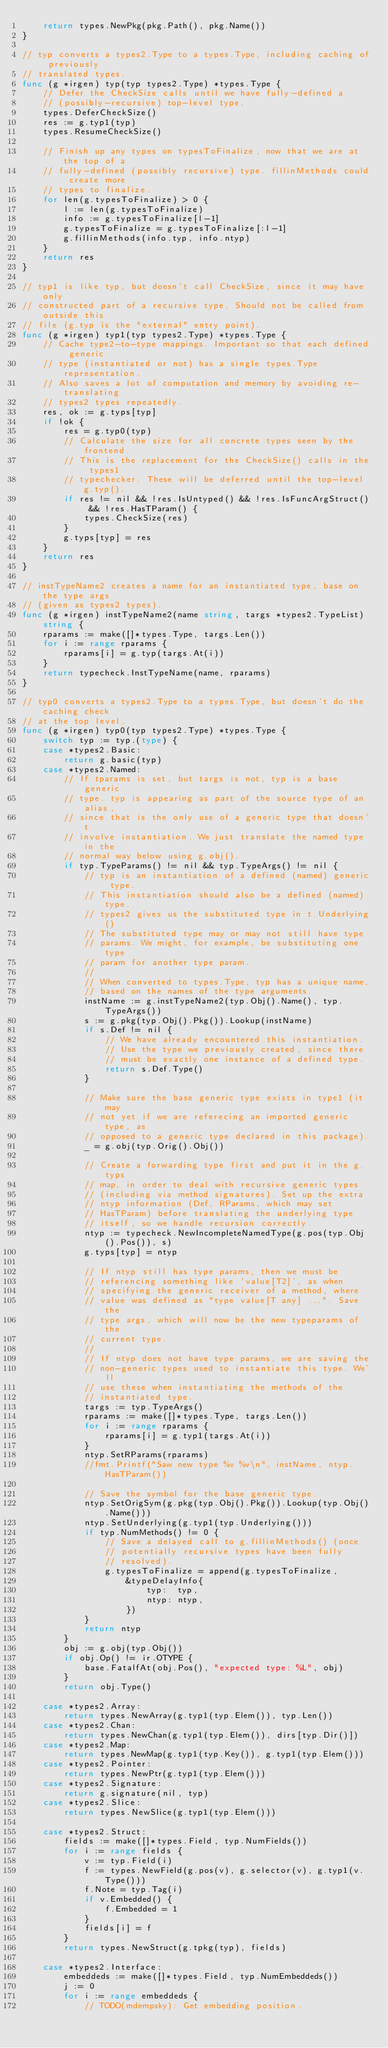Convert code to text. <code><loc_0><loc_0><loc_500><loc_500><_Go_>	return types.NewPkg(pkg.Path(), pkg.Name())
}

// typ converts a types2.Type to a types.Type, including caching of previously
// translated types.
func (g *irgen) typ(typ types2.Type) *types.Type {
	// Defer the CheckSize calls until we have fully-defined a
	// (possibly-recursive) top-level type.
	types.DeferCheckSize()
	res := g.typ1(typ)
	types.ResumeCheckSize()

	// Finish up any types on typesToFinalize, now that we are at the top of a
	// fully-defined (possibly recursive) type. fillinMethods could create more
	// types to finalize.
	for len(g.typesToFinalize) > 0 {
		l := len(g.typesToFinalize)
		info := g.typesToFinalize[l-1]
		g.typesToFinalize = g.typesToFinalize[:l-1]
		g.fillinMethods(info.typ, info.ntyp)
	}
	return res
}

// typ1 is like typ, but doesn't call CheckSize, since it may have only
// constructed part of a recursive type. Should not be called from outside this
// file (g.typ is the "external" entry point).
func (g *irgen) typ1(typ types2.Type) *types.Type {
	// Cache type2-to-type mappings. Important so that each defined generic
	// type (instantiated or not) has a single types.Type representation.
	// Also saves a lot of computation and memory by avoiding re-translating
	// types2 types repeatedly.
	res, ok := g.typs[typ]
	if !ok {
		res = g.typ0(typ)
		// Calculate the size for all concrete types seen by the frontend.
		// This is the replacement for the CheckSize() calls in the types1
		// typechecker. These will be deferred until the top-level g.typ().
		if res != nil && !res.IsUntyped() && !res.IsFuncArgStruct() && !res.HasTParam() {
			types.CheckSize(res)
		}
		g.typs[typ] = res
	}
	return res
}

// instTypeName2 creates a name for an instantiated type, base on the type args
// (given as types2 types).
func (g *irgen) instTypeName2(name string, targs *types2.TypeList) string {
	rparams := make([]*types.Type, targs.Len())
	for i := range rparams {
		rparams[i] = g.typ(targs.At(i))
	}
	return typecheck.InstTypeName(name, rparams)
}

// typ0 converts a types2.Type to a types.Type, but doesn't do the caching check
// at the top level.
func (g *irgen) typ0(typ types2.Type) *types.Type {
	switch typ := typ.(type) {
	case *types2.Basic:
		return g.basic(typ)
	case *types2.Named:
		// If tparams is set, but targs is not, typ is a base generic
		// type. typ is appearing as part of the source type of an alias,
		// since that is the only use of a generic type that doesn't
		// involve instantiation. We just translate the named type in the
		// normal way below using g.obj().
		if typ.TypeParams() != nil && typ.TypeArgs() != nil {
			// typ is an instantiation of a defined (named) generic type.
			// This instantiation should also be a defined (named) type.
			// types2 gives us the substituted type in t.Underlying()
			// The substituted type may or may not still have type
			// params. We might, for example, be substituting one type
			// param for another type param.
			//
			// When converted to types.Type, typ has a unique name,
			// based on the names of the type arguments.
			instName := g.instTypeName2(typ.Obj().Name(), typ.TypeArgs())
			s := g.pkg(typ.Obj().Pkg()).Lookup(instName)
			if s.Def != nil {
				// We have already encountered this instantiation.
				// Use the type we previously created, since there
				// must be exactly one instance of a defined type.
				return s.Def.Type()
			}

			// Make sure the base generic type exists in type1 (it may
			// not yet if we are referecing an imported generic type, as
			// opposed to a generic type declared in this package).
			_ = g.obj(typ.Orig().Obj())

			// Create a forwarding type first and put it in the g.typs
			// map, in order to deal with recursive generic types
			// (including via method signatures). Set up the extra
			// ntyp information (Def, RParams, which may set
			// HasTParam) before translating the underlying type
			// itself, so we handle recursion correctly.
			ntyp := typecheck.NewIncompleteNamedType(g.pos(typ.Obj().Pos()), s)
			g.typs[typ] = ntyp

			// If ntyp still has type params, then we must be
			// referencing something like 'value[T2]', as when
			// specifying the generic receiver of a method, where
			// value was defined as "type value[T any] ...". Save the
			// type args, which will now be the new typeparams of the
			// current type.
			//
			// If ntyp does not have type params, we are saving the
			// non-generic types used to instantiate this type. We'll
			// use these when instantiating the methods of the
			// instantiated type.
			targs := typ.TypeArgs()
			rparams := make([]*types.Type, targs.Len())
			for i := range rparams {
				rparams[i] = g.typ1(targs.At(i))
			}
			ntyp.SetRParams(rparams)
			//fmt.Printf("Saw new type %v %v\n", instName, ntyp.HasTParam())

			// Save the symbol for the base generic type.
			ntyp.SetOrigSym(g.pkg(typ.Obj().Pkg()).Lookup(typ.Obj().Name()))
			ntyp.SetUnderlying(g.typ1(typ.Underlying()))
			if typ.NumMethods() != 0 {
				// Save a delayed call to g.fillinMethods() (once
				// potentially recursive types have been fully
				// resolved).
				g.typesToFinalize = append(g.typesToFinalize,
					&typeDelayInfo{
						typ:  typ,
						ntyp: ntyp,
					})
			}
			return ntyp
		}
		obj := g.obj(typ.Obj())
		if obj.Op() != ir.OTYPE {
			base.FatalfAt(obj.Pos(), "expected type: %L", obj)
		}
		return obj.Type()

	case *types2.Array:
		return types.NewArray(g.typ1(typ.Elem()), typ.Len())
	case *types2.Chan:
		return types.NewChan(g.typ1(typ.Elem()), dirs[typ.Dir()])
	case *types2.Map:
		return types.NewMap(g.typ1(typ.Key()), g.typ1(typ.Elem()))
	case *types2.Pointer:
		return types.NewPtr(g.typ1(typ.Elem()))
	case *types2.Signature:
		return g.signature(nil, typ)
	case *types2.Slice:
		return types.NewSlice(g.typ1(typ.Elem()))

	case *types2.Struct:
		fields := make([]*types.Field, typ.NumFields())
		for i := range fields {
			v := typ.Field(i)
			f := types.NewField(g.pos(v), g.selector(v), g.typ1(v.Type()))
			f.Note = typ.Tag(i)
			if v.Embedded() {
				f.Embedded = 1
			}
			fields[i] = f
		}
		return types.NewStruct(g.tpkg(typ), fields)

	case *types2.Interface:
		embeddeds := make([]*types.Field, typ.NumEmbeddeds())
		j := 0
		for i := range embeddeds {
			// TODO(mdempsky): Get embedding position.</code> 